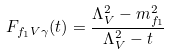Convert formula to latex. <formula><loc_0><loc_0><loc_500><loc_500>F _ { f _ { 1 } V \gamma } ( t ) = \frac { \Lambda _ { V } ^ { 2 } - m _ { f _ { 1 } } ^ { 2 } } { \Lambda _ { V } ^ { 2 } - t }</formula> 